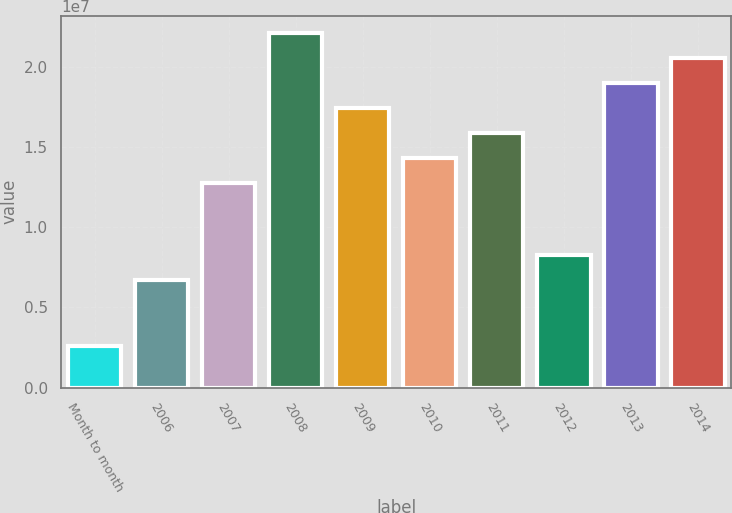Convert chart. <chart><loc_0><loc_0><loc_500><loc_500><bar_chart><fcel>Month to month<fcel>2006<fcel>2007<fcel>2008<fcel>2009<fcel>2010<fcel>2011<fcel>2012<fcel>2013<fcel>2014<nl><fcel>2.578e+06<fcel>6.702e+06<fcel>1.2787e+07<fcel>2.20924e+07<fcel>1.74397e+07<fcel>1.43379e+07<fcel>1.58888e+07<fcel>8.2529e+06<fcel>1.89906e+07<fcel>2.05415e+07<nl></chart> 